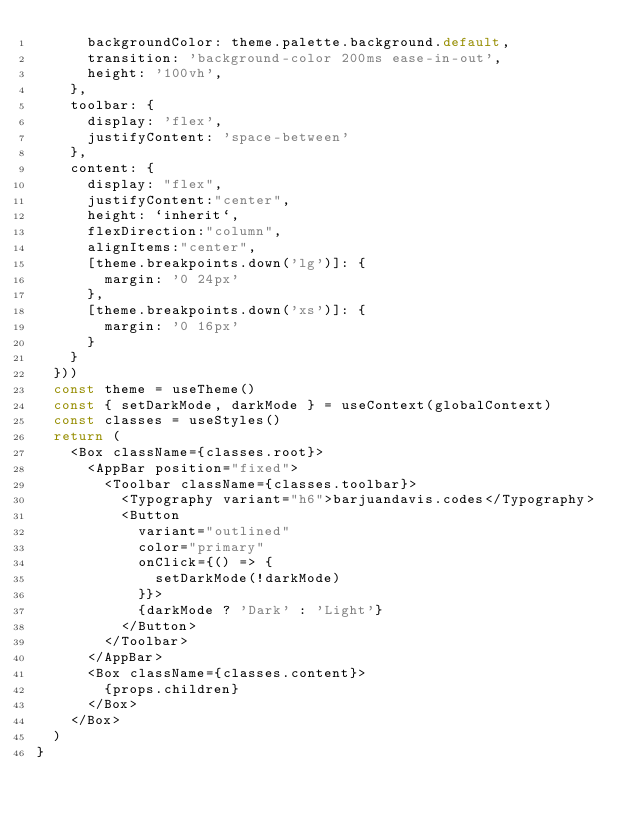<code> <loc_0><loc_0><loc_500><loc_500><_JavaScript_>      backgroundColor: theme.palette.background.default,
      transition: 'background-color 200ms ease-in-out',
      height: '100vh',
    },
    toolbar: {
      display: 'flex',
      justifyContent: 'space-between'
    },
    content: {
      display: "flex",
      justifyContent:"center",
      height: `inherit`,
      flexDirection:"column",
      alignItems:"center",
      [theme.breakpoints.down('lg')]: {
        margin: '0 24px'
      },
      [theme.breakpoints.down('xs')]: {
        margin: '0 16px'
      }
    }
  }))
  const theme = useTheme()
  const { setDarkMode, darkMode } = useContext(globalContext)
  const classes = useStyles()
  return (
    <Box className={classes.root}>
      <AppBar position="fixed">
        <Toolbar className={classes.toolbar}>
          <Typography variant="h6">barjuandavis.codes</Typography>
          <Button
            variant="outlined"
            color="primary"
            onClick={() => {
              setDarkMode(!darkMode)
            }}>
            {darkMode ? 'Dark' : 'Light'}
          </Button>
        </Toolbar>
      </AppBar>
      <Box className={classes.content}>
        {props.children}
      </Box>
    </Box>
  )
}
</code> 